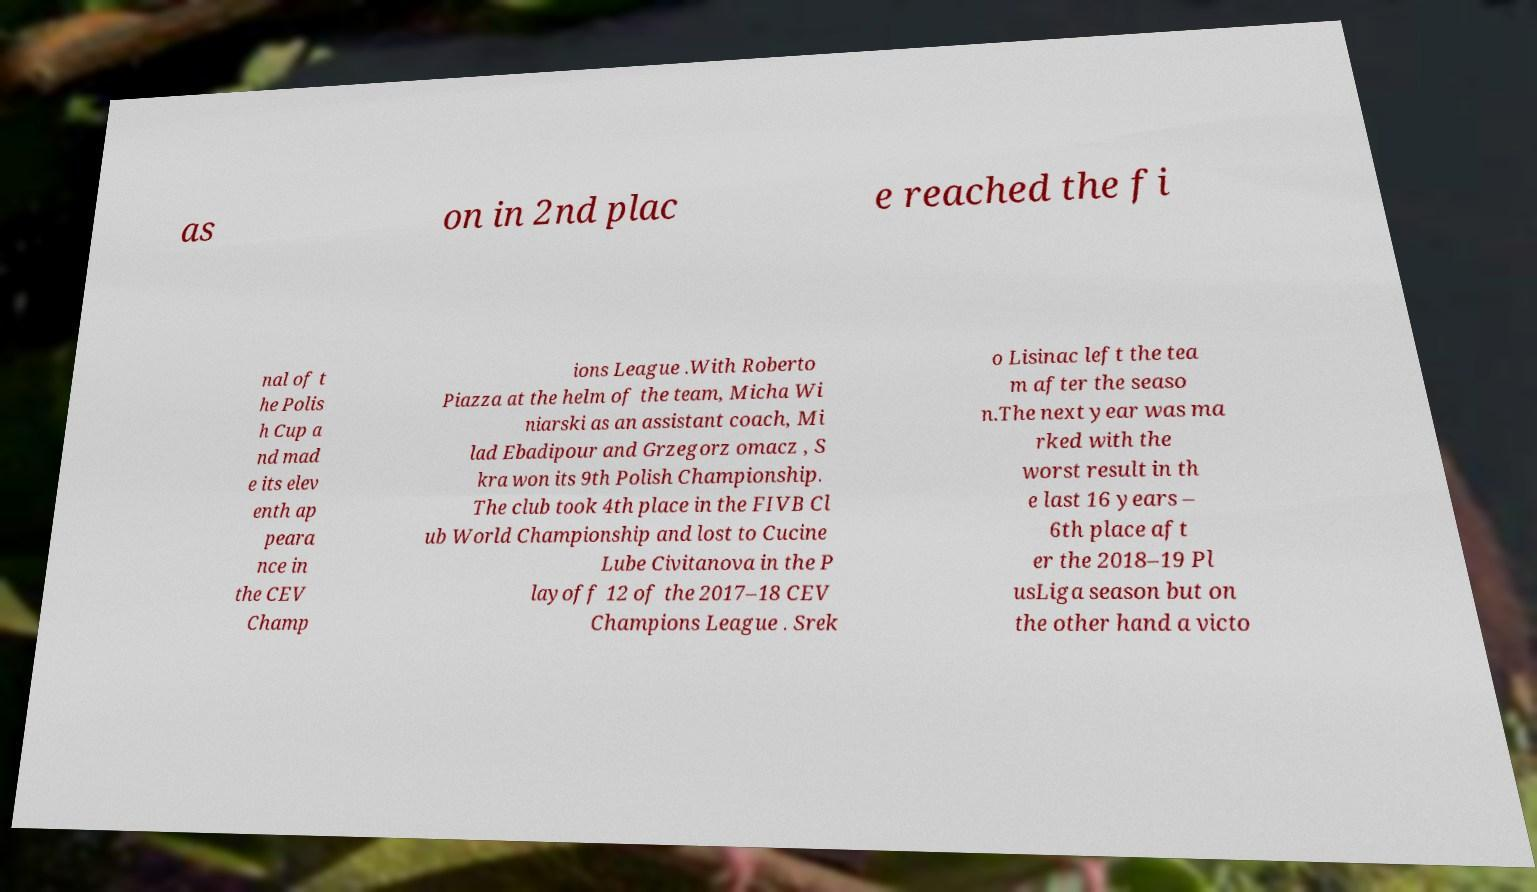Can you accurately transcribe the text from the provided image for me? as on in 2nd plac e reached the fi nal of t he Polis h Cup a nd mad e its elev enth ap peara nce in the CEV Champ ions League .With Roberto Piazza at the helm of the team, Micha Wi niarski as an assistant coach, Mi lad Ebadipour and Grzegorz omacz , S kra won its 9th Polish Championship. The club took 4th place in the FIVB Cl ub World Championship and lost to Cucine Lube Civitanova in the P layoff 12 of the 2017–18 CEV Champions League . Srek o Lisinac left the tea m after the seaso n.The next year was ma rked with the worst result in th e last 16 years – 6th place aft er the 2018–19 Pl usLiga season but on the other hand a victo 